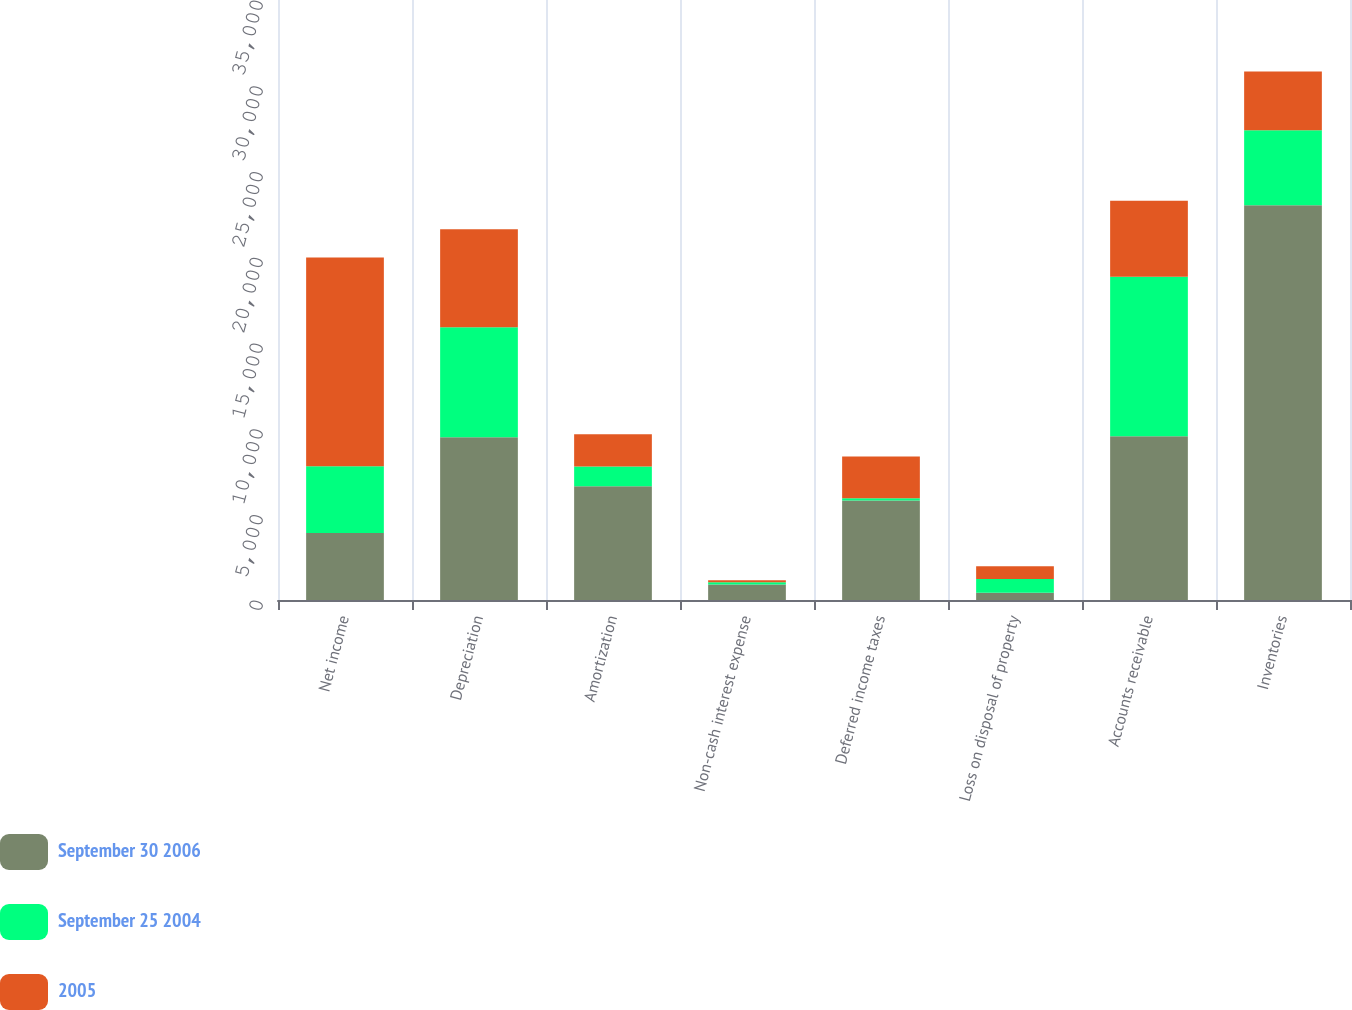<chart> <loc_0><loc_0><loc_500><loc_500><stacked_bar_chart><ecel><fcel>Net income<fcel>Depreciation<fcel>Amortization<fcel>Non-cash interest expense<fcel>Deferred income taxes<fcel>Loss on disposal of property<fcel>Accounts receivable<fcel>Inventories<nl><fcel>September 30 2006<fcel>3904.5<fcel>9492<fcel>6641<fcel>899<fcel>5797<fcel>420<fcel>9545<fcel>23023<nl><fcel>September 25 2004<fcel>3904.5<fcel>6421<fcel>1153<fcel>133<fcel>135<fcel>805<fcel>9310<fcel>4381<nl><fcel>2005<fcel>12164<fcel>5712<fcel>1877<fcel>123<fcel>2436<fcel>744<fcel>4435<fcel>3428<nl></chart> 